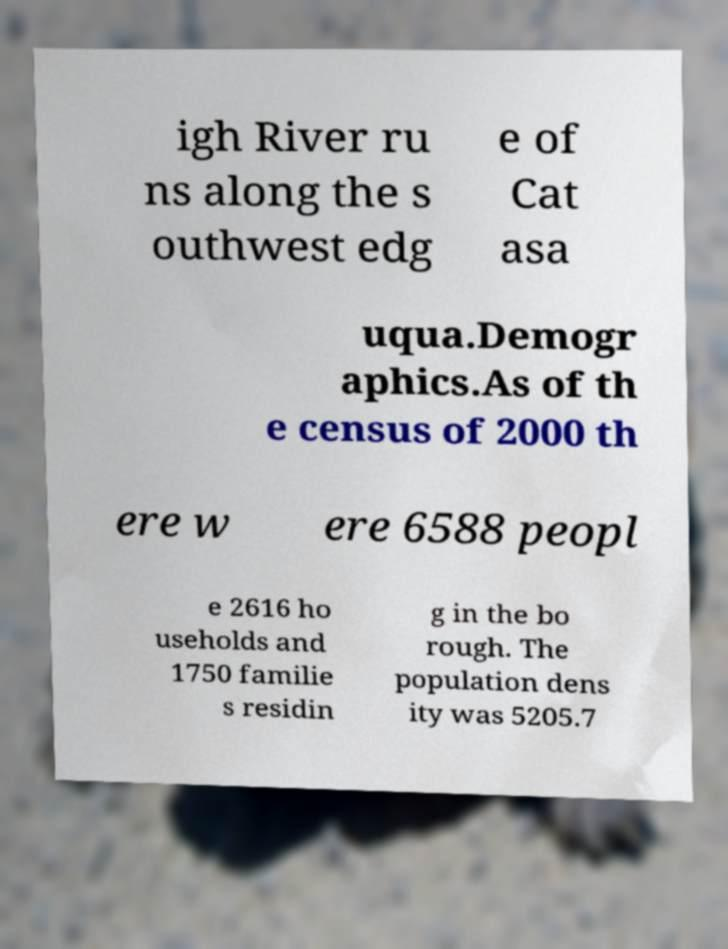Can you accurately transcribe the text from the provided image for me? igh River ru ns along the s outhwest edg e of Cat asa uqua.Demogr aphics.As of th e census of 2000 th ere w ere 6588 peopl e 2616 ho useholds and 1750 familie s residin g in the bo rough. The population dens ity was 5205.7 